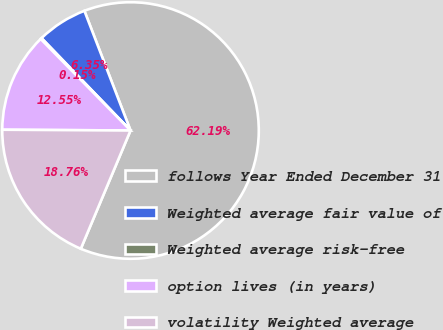<chart> <loc_0><loc_0><loc_500><loc_500><pie_chart><fcel>follows Year Ended December 31<fcel>Weighted average fair value of<fcel>Weighted average risk-free<fcel>option lives (in years)<fcel>volatility Weighted average<nl><fcel>62.19%<fcel>6.35%<fcel>0.15%<fcel>12.55%<fcel>18.76%<nl></chart> 